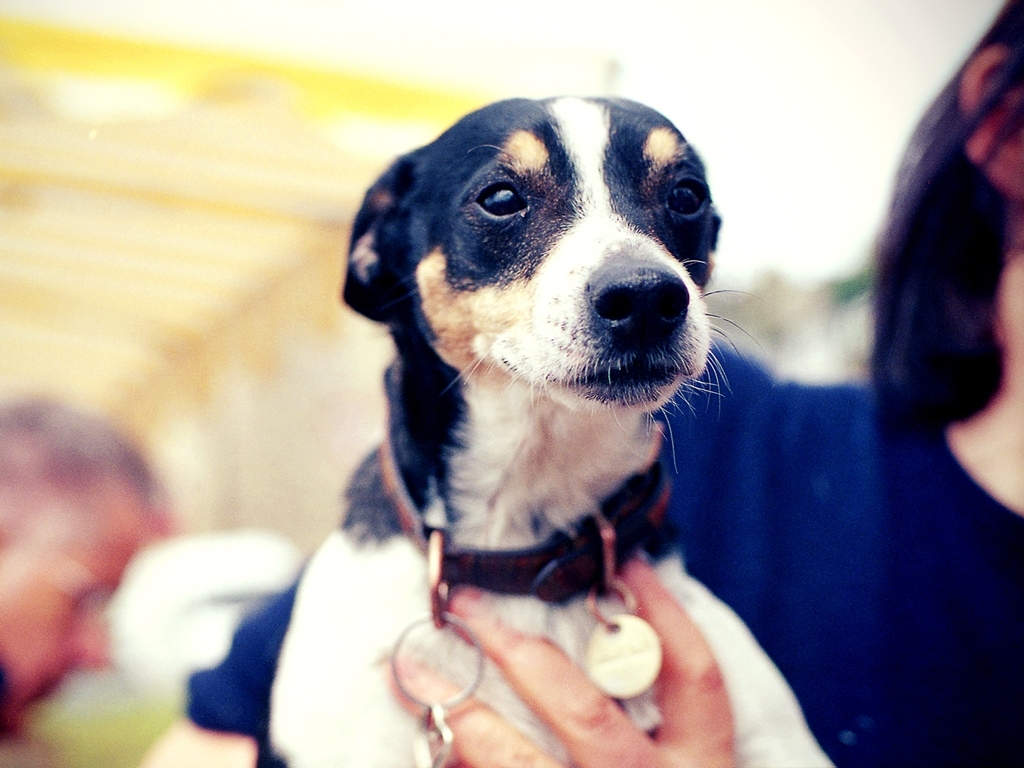What breed of dog is shown in the picture? The dog appears to be a mixed breed with some characteristics of a Rat Terrier or similar small hunting dog breed. 